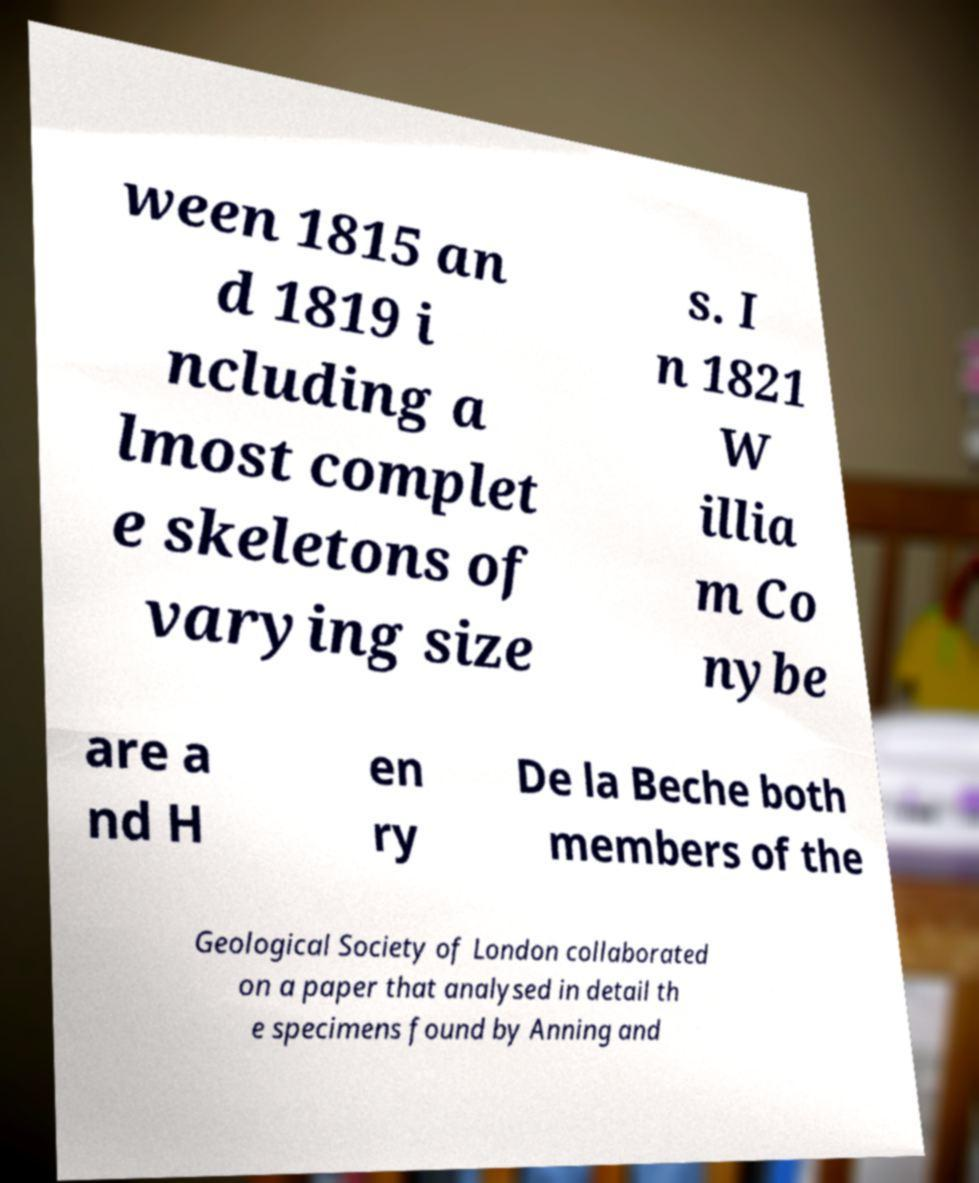Could you assist in decoding the text presented in this image and type it out clearly? ween 1815 an d 1819 i ncluding a lmost complet e skeletons of varying size s. I n 1821 W illia m Co nybe are a nd H en ry De la Beche both members of the Geological Society of London collaborated on a paper that analysed in detail th e specimens found by Anning and 